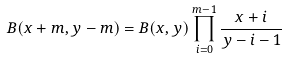Convert formula to latex. <formula><loc_0><loc_0><loc_500><loc_500>B ( x + m , y - m ) = B ( x , y ) \prod _ { i = 0 } ^ { m - 1 } \frac { x + i } { y - i - 1 }</formula> 